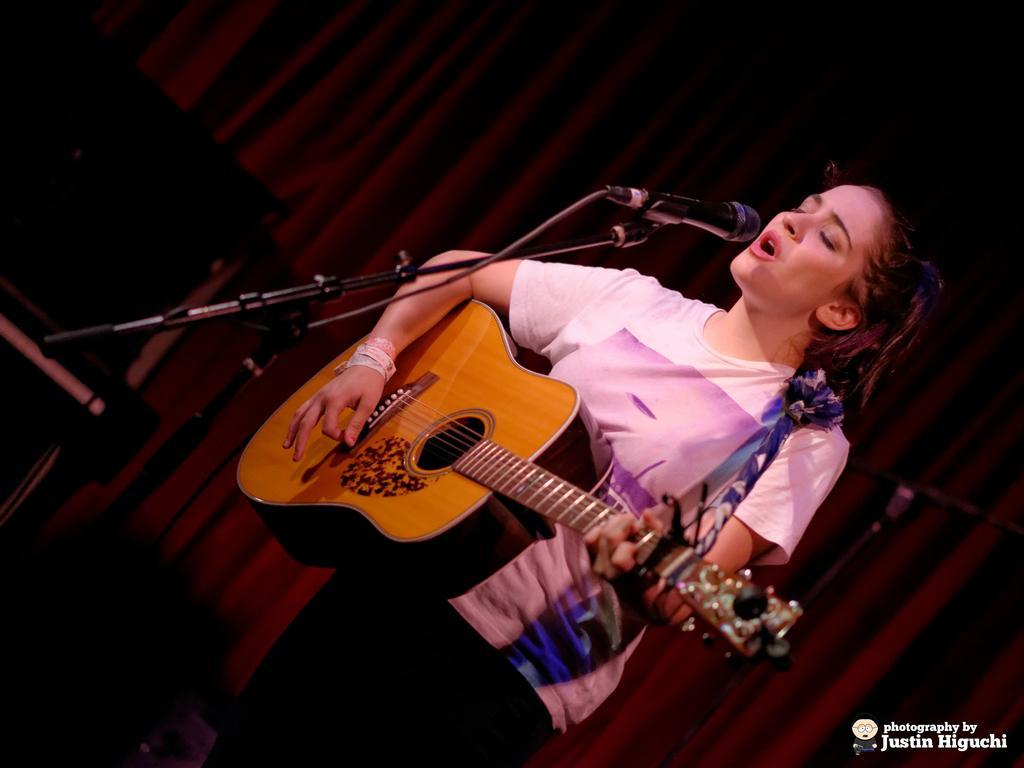Can you describe this image briefly? This is a picture of a woman in white t shirt was standing on the stage and holding a guitar and the woman is singing a song in front of the man there is a microphone with stand. Behind the woman there is a red curtain and on the image there is a watermark. 